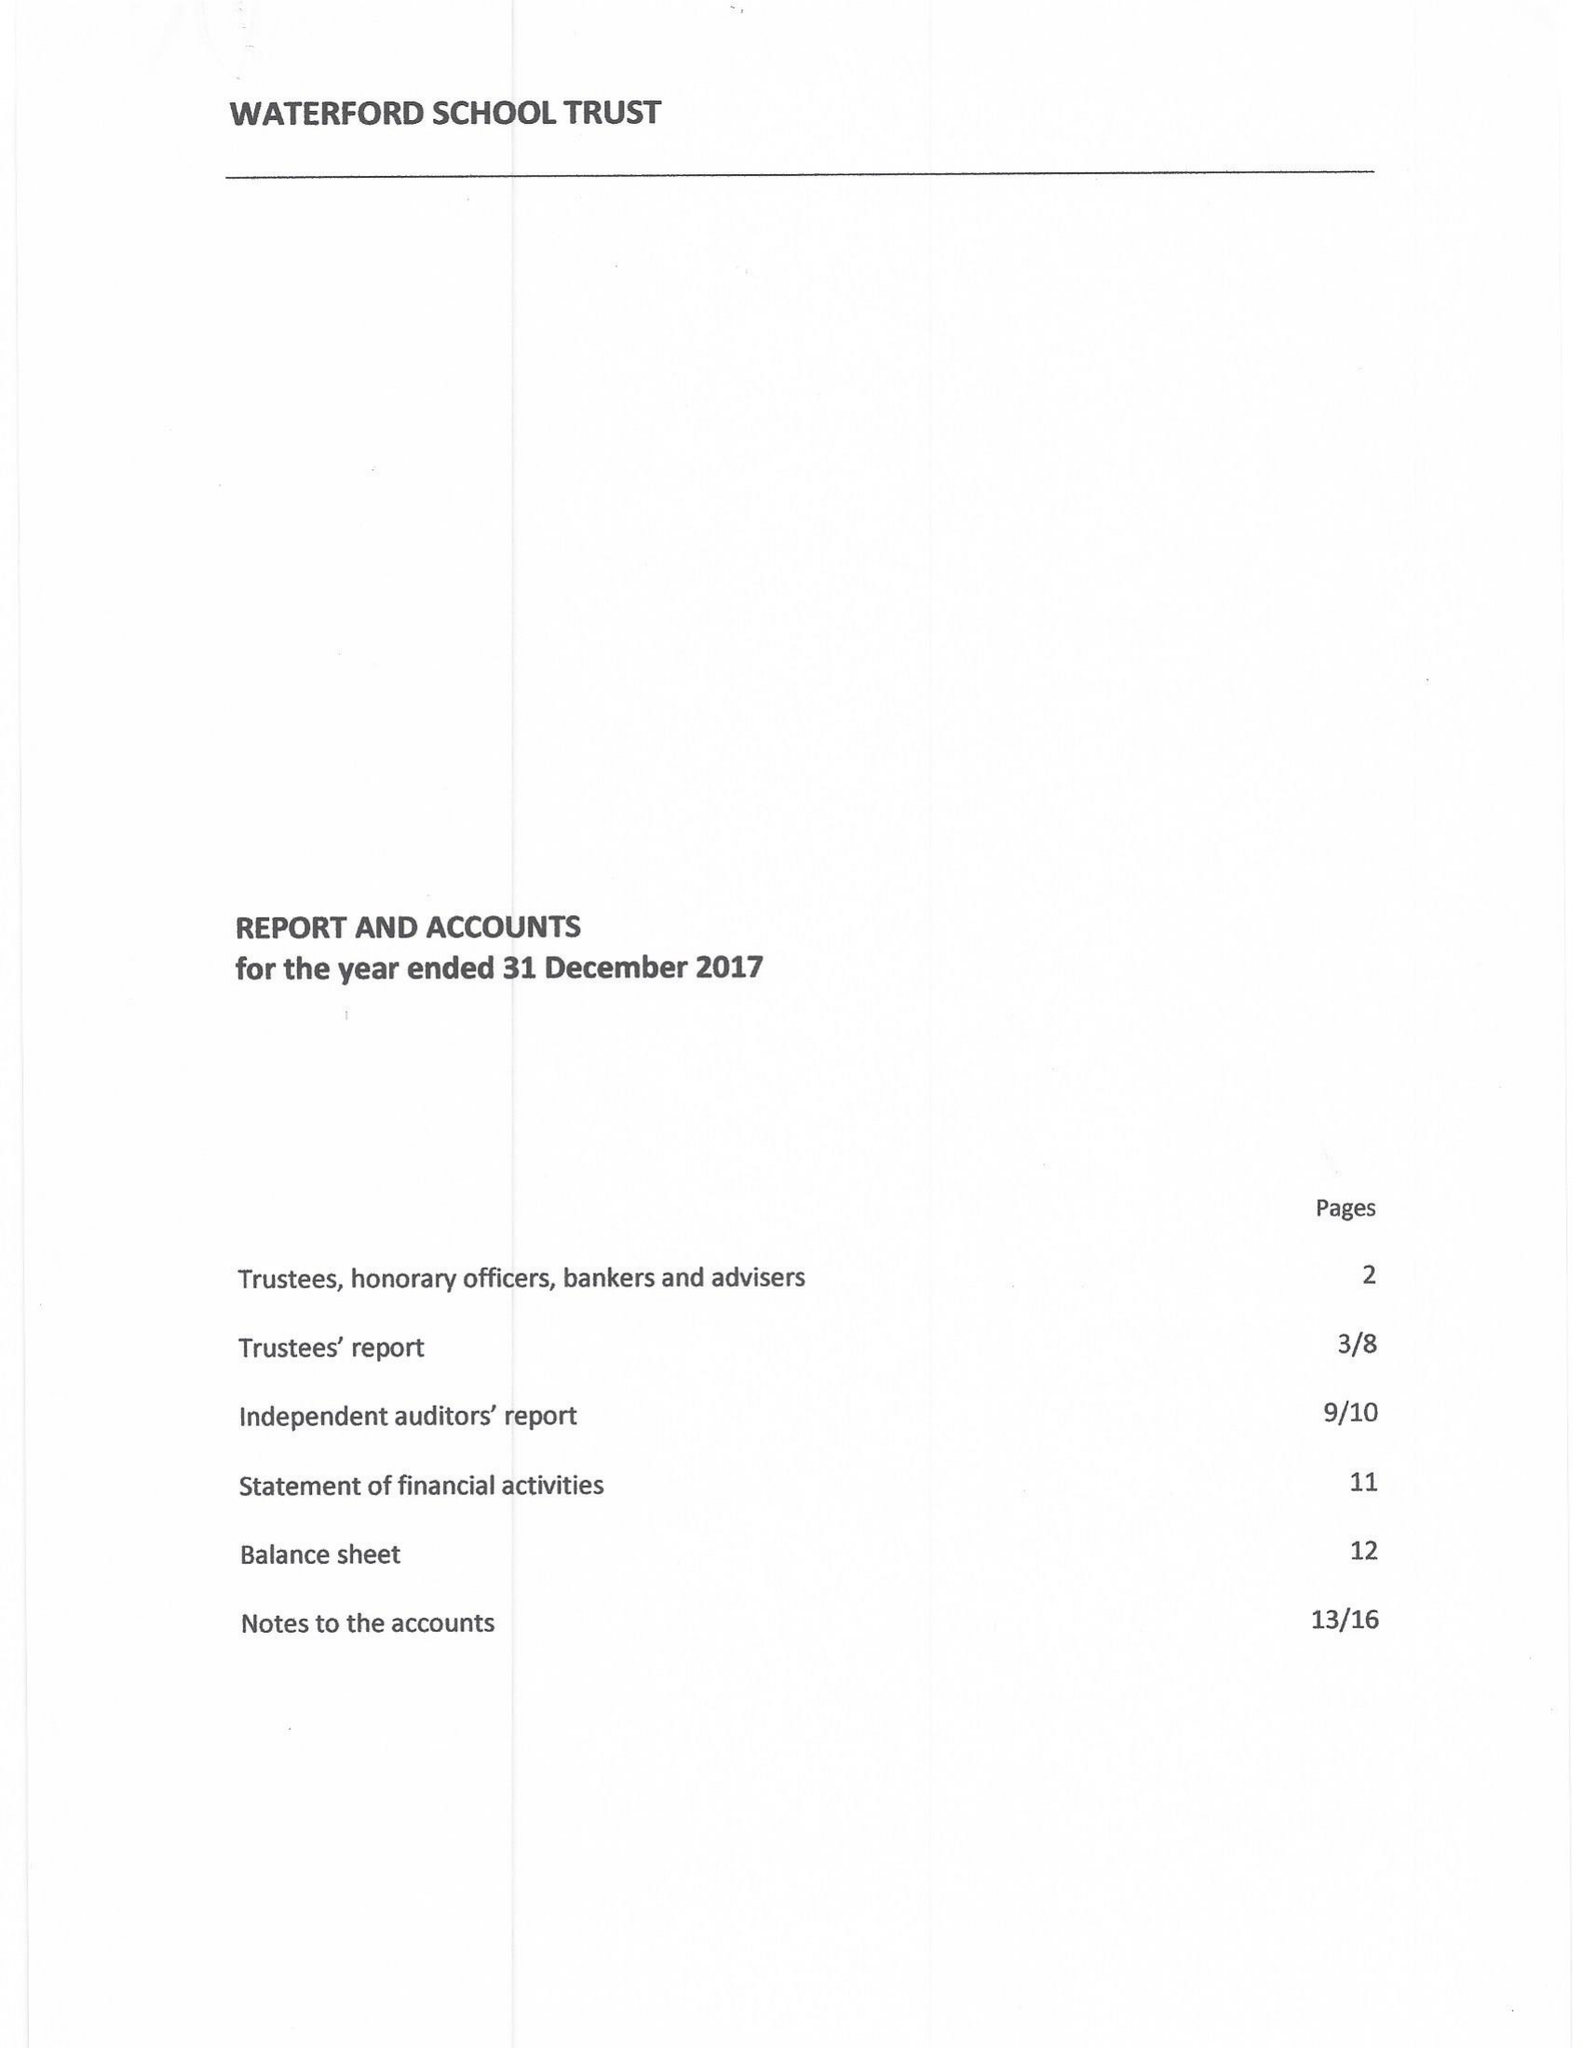What is the value for the address__post_town?
Answer the question using a single word or phrase. LONDON 